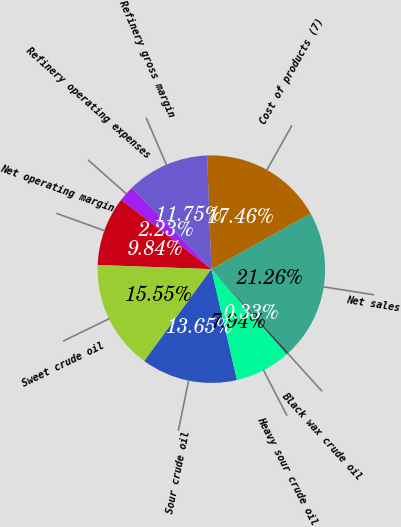<chart> <loc_0><loc_0><loc_500><loc_500><pie_chart><fcel>Net sales<fcel>Cost of products (7)<fcel>Refinery gross margin<fcel>Refinery operating expenses<fcel>Net operating margin<fcel>Sweet crude oil<fcel>Sour crude oil<fcel>Heavy sour crude oil<fcel>Black wax crude oil<nl><fcel>21.26%<fcel>17.46%<fcel>11.75%<fcel>2.23%<fcel>9.84%<fcel>15.55%<fcel>13.65%<fcel>7.94%<fcel>0.33%<nl></chart> 